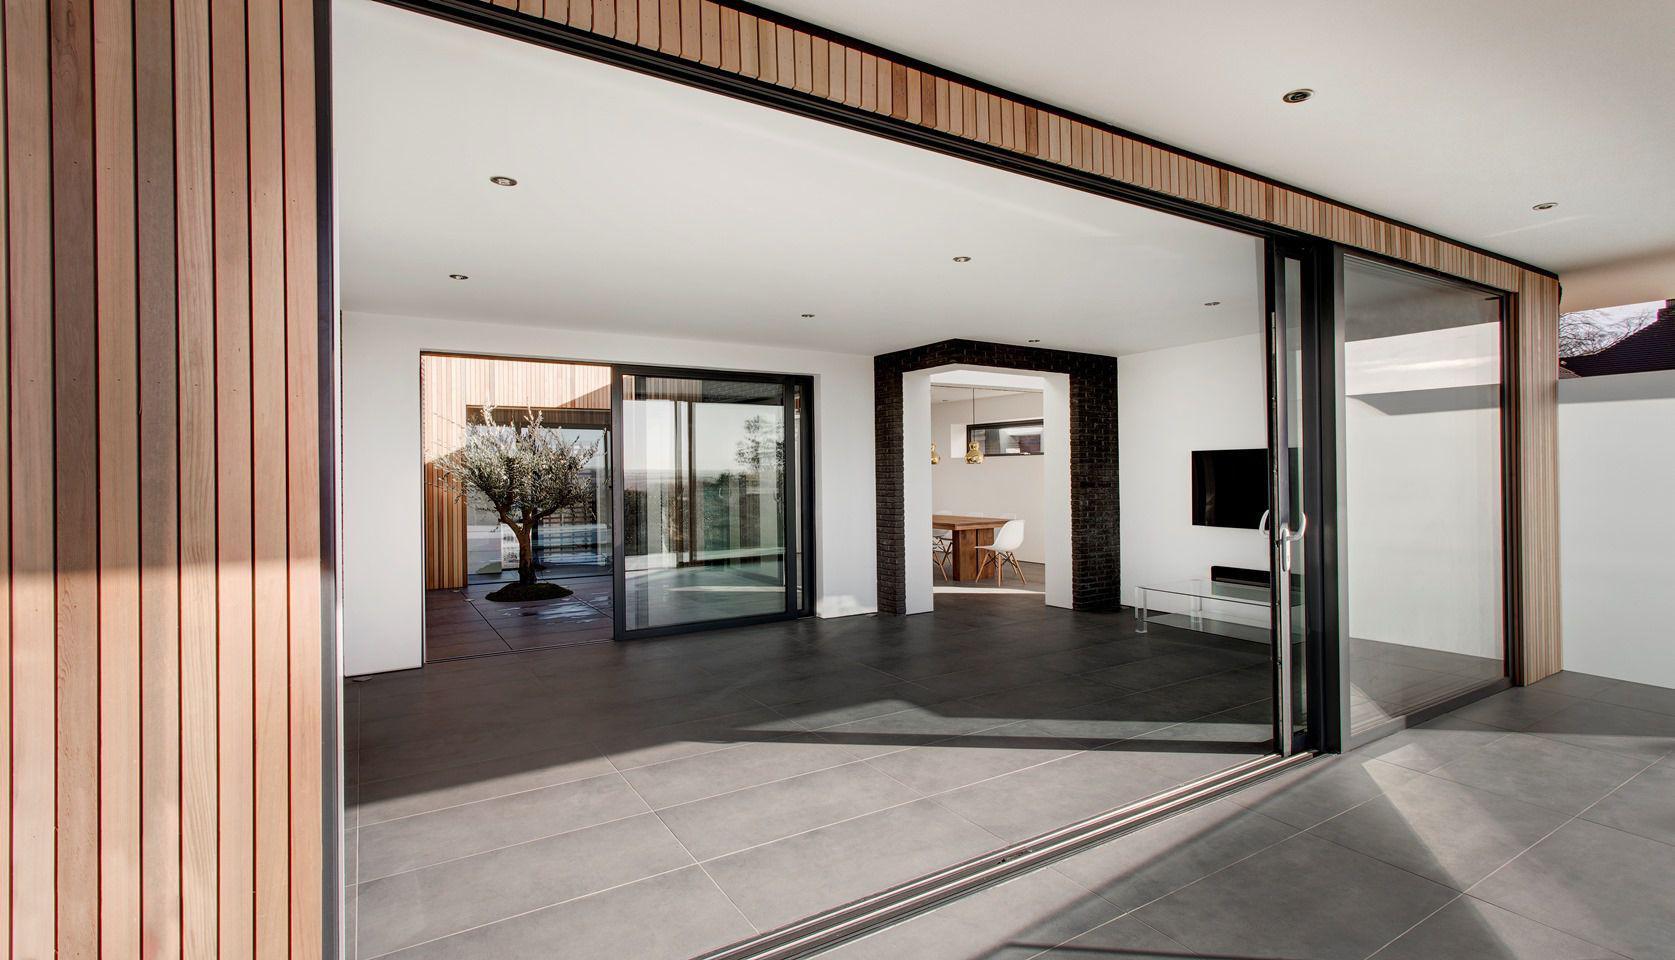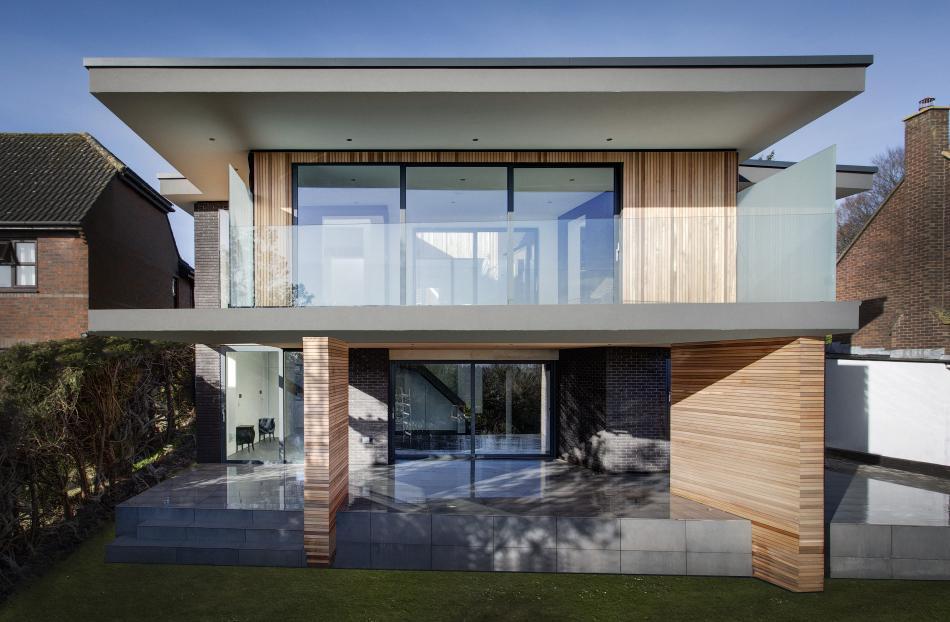The first image is the image on the left, the second image is the image on the right. For the images displayed, is the sentence "The doors are open in both images." factually correct? Answer yes or no. No. 